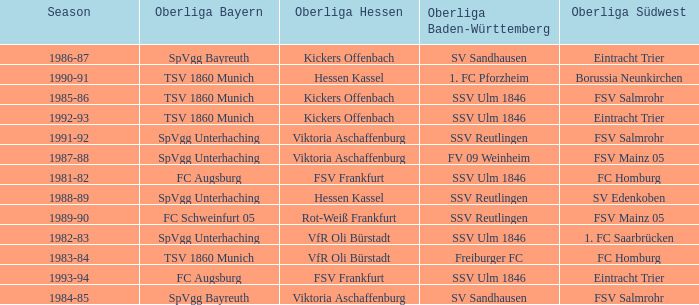Which oberliga baden-württemberg has a season of 1991-92? SSV Reutlingen. 